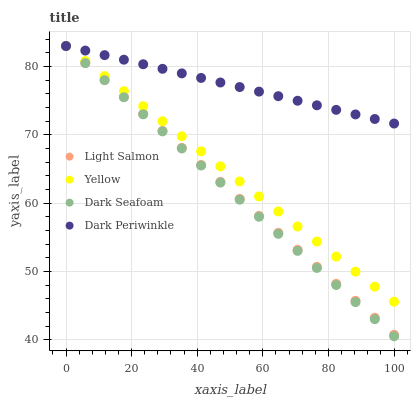Does Dark Seafoam have the minimum area under the curve?
Answer yes or no. Yes. Does Dark Periwinkle have the maximum area under the curve?
Answer yes or no. Yes. Does Yellow have the minimum area under the curve?
Answer yes or no. No. Does Yellow have the maximum area under the curve?
Answer yes or no. No. Is Light Salmon the smoothest?
Answer yes or no. Yes. Is Dark Periwinkle the roughest?
Answer yes or no. Yes. Is Dark Seafoam the smoothest?
Answer yes or no. No. Is Dark Seafoam the roughest?
Answer yes or no. No. Does Dark Seafoam have the lowest value?
Answer yes or no. Yes. Does Yellow have the lowest value?
Answer yes or no. No. Does Dark Periwinkle have the highest value?
Answer yes or no. Yes. Does Dark Periwinkle intersect Light Salmon?
Answer yes or no. Yes. Is Dark Periwinkle less than Light Salmon?
Answer yes or no. No. Is Dark Periwinkle greater than Light Salmon?
Answer yes or no. No. 